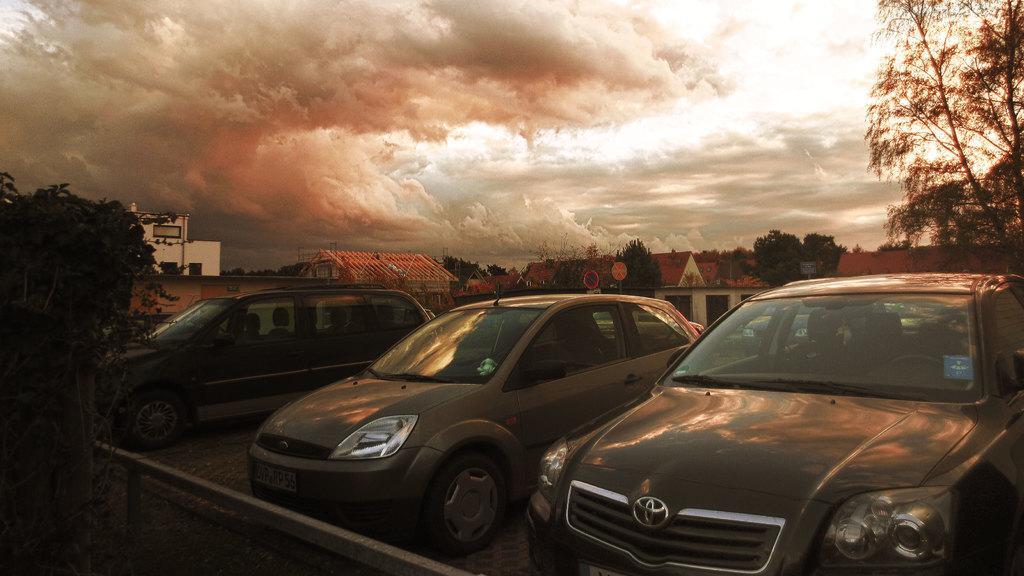Describe this image in one or two sentences. In this image we can see some cars placed on the footpath. We can also see trees, houses with roofs, sign boards, pole and the sky which looks cloudy. 